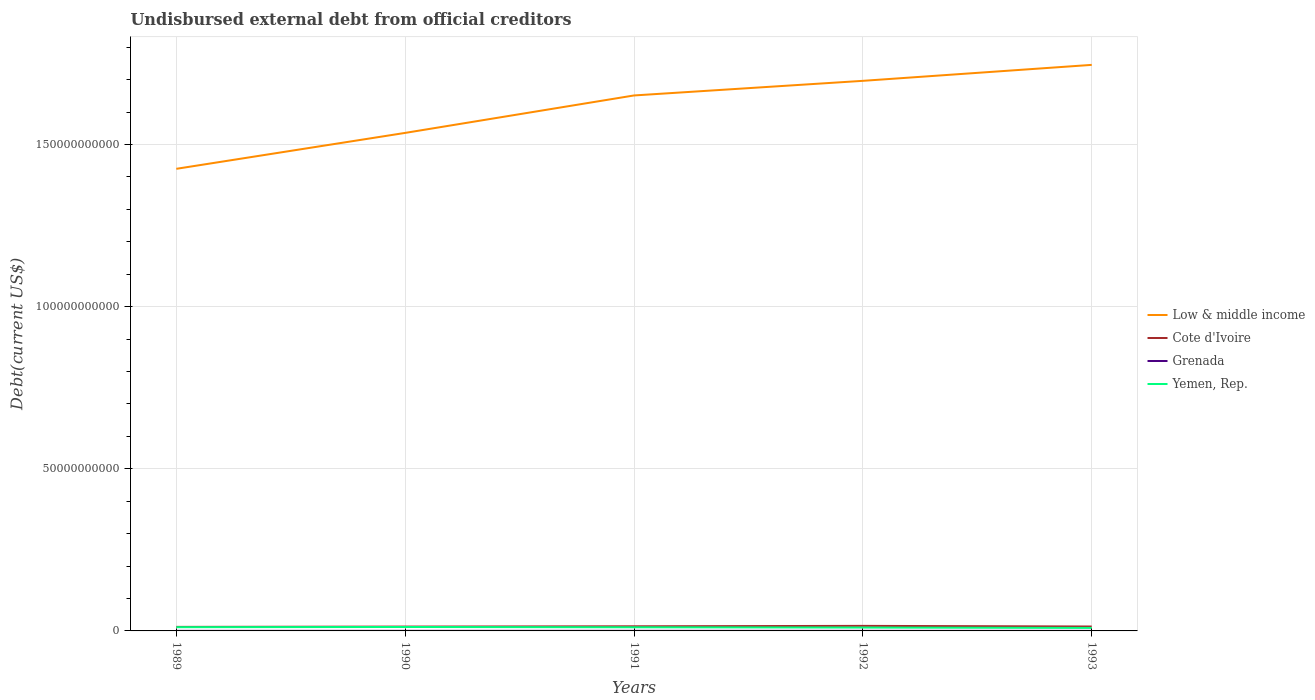Is the number of lines equal to the number of legend labels?
Ensure brevity in your answer.  Yes. Across all years, what is the maximum total debt in Grenada?
Keep it short and to the point. 1.79e+07. In which year was the total debt in Low & middle income maximum?
Give a very brief answer. 1989. What is the total total debt in Cote d'Ivoire in the graph?
Ensure brevity in your answer.  -2.43e+07. What is the difference between the highest and the second highest total debt in Grenada?
Provide a succinct answer. 8.83e+06. What is the difference between the highest and the lowest total debt in Cote d'Ivoire?
Your response must be concise. 2. How many lines are there?
Make the answer very short. 4. How many years are there in the graph?
Ensure brevity in your answer.  5. What is the difference between two consecutive major ticks on the Y-axis?
Make the answer very short. 5.00e+1. Are the values on the major ticks of Y-axis written in scientific E-notation?
Your response must be concise. No. Does the graph contain any zero values?
Your response must be concise. No. Does the graph contain grids?
Your response must be concise. Yes. How many legend labels are there?
Give a very brief answer. 4. How are the legend labels stacked?
Provide a succinct answer. Vertical. What is the title of the graph?
Make the answer very short. Undisbursed external debt from official creditors. What is the label or title of the X-axis?
Provide a succinct answer. Years. What is the label or title of the Y-axis?
Provide a succinct answer. Debt(current US$). What is the Debt(current US$) in Low & middle income in 1989?
Provide a short and direct response. 1.42e+11. What is the Debt(current US$) of Cote d'Ivoire in 1989?
Keep it short and to the point. 1.24e+09. What is the Debt(current US$) of Grenada in 1989?
Give a very brief answer. 1.99e+07. What is the Debt(current US$) in Yemen, Rep. in 1989?
Offer a terse response. 1.15e+09. What is the Debt(current US$) in Low & middle income in 1990?
Your answer should be compact. 1.54e+11. What is the Debt(current US$) in Cote d'Ivoire in 1990?
Ensure brevity in your answer.  1.33e+09. What is the Debt(current US$) of Grenada in 1990?
Offer a very short reply. 2.45e+07. What is the Debt(current US$) of Yemen, Rep. in 1990?
Ensure brevity in your answer.  1.21e+09. What is the Debt(current US$) in Low & middle income in 1991?
Your response must be concise. 1.65e+11. What is the Debt(current US$) in Cote d'Ivoire in 1991?
Your answer should be very brief. 1.43e+09. What is the Debt(current US$) in Grenada in 1991?
Offer a very short reply. 2.68e+07. What is the Debt(current US$) of Yemen, Rep. in 1991?
Your answer should be very brief. 1.12e+09. What is the Debt(current US$) of Low & middle income in 1992?
Keep it short and to the point. 1.70e+11. What is the Debt(current US$) of Cote d'Ivoire in 1992?
Ensure brevity in your answer.  1.56e+09. What is the Debt(current US$) in Grenada in 1992?
Offer a terse response. 2.27e+07. What is the Debt(current US$) of Yemen, Rep. in 1992?
Offer a terse response. 1.04e+09. What is the Debt(current US$) in Low & middle income in 1993?
Your answer should be compact. 1.75e+11. What is the Debt(current US$) of Cote d'Ivoire in 1993?
Your answer should be very brief. 1.36e+09. What is the Debt(current US$) of Grenada in 1993?
Your response must be concise. 1.79e+07. What is the Debt(current US$) in Yemen, Rep. in 1993?
Your answer should be compact. 9.25e+08. Across all years, what is the maximum Debt(current US$) in Low & middle income?
Ensure brevity in your answer.  1.75e+11. Across all years, what is the maximum Debt(current US$) of Cote d'Ivoire?
Provide a succinct answer. 1.56e+09. Across all years, what is the maximum Debt(current US$) of Grenada?
Provide a short and direct response. 2.68e+07. Across all years, what is the maximum Debt(current US$) of Yemen, Rep.?
Keep it short and to the point. 1.21e+09. Across all years, what is the minimum Debt(current US$) in Low & middle income?
Your response must be concise. 1.42e+11. Across all years, what is the minimum Debt(current US$) in Cote d'Ivoire?
Provide a succinct answer. 1.24e+09. Across all years, what is the minimum Debt(current US$) of Grenada?
Provide a short and direct response. 1.79e+07. Across all years, what is the minimum Debt(current US$) in Yemen, Rep.?
Offer a terse response. 9.25e+08. What is the total Debt(current US$) of Low & middle income in the graph?
Your response must be concise. 8.05e+11. What is the total Debt(current US$) in Cote d'Ivoire in the graph?
Provide a succinct answer. 6.92e+09. What is the total Debt(current US$) in Grenada in the graph?
Your answer should be compact. 1.12e+08. What is the total Debt(current US$) of Yemen, Rep. in the graph?
Your answer should be very brief. 5.45e+09. What is the difference between the Debt(current US$) of Low & middle income in 1989 and that in 1990?
Offer a terse response. -1.11e+1. What is the difference between the Debt(current US$) of Cote d'Ivoire in 1989 and that in 1990?
Offer a very short reply. -9.09e+07. What is the difference between the Debt(current US$) in Grenada in 1989 and that in 1990?
Give a very brief answer. -4.60e+06. What is the difference between the Debt(current US$) of Yemen, Rep. in 1989 and that in 1990?
Make the answer very short. -6.36e+07. What is the difference between the Debt(current US$) of Low & middle income in 1989 and that in 1991?
Ensure brevity in your answer.  -2.26e+1. What is the difference between the Debt(current US$) in Cote d'Ivoire in 1989 and that in 1991?
Offer a terse response. -1.83e+08. What is the difference between the Debt(current US$) in Grenada in 1989 and that in 1991?
Offer a very short reply. -6.82e+06. What is the difference between the Debt(current US$) of Yemen, Rep. in 1989 and that in 1991?
Your answer should be compact. 2.75e+07. What is the difference between the Debt(current US$) in Low & middle income in 1989 and that in 1992?
Offer a very short reply. -2.71e+1. What is the difference between the Debt(current US$) in Cote d'Ivoire in 1989 and that in 1992?
Ensure brevity in your answer.  -3.12e+08. What is the difference between the Debt(current US$) of Grenada in 1989 and that in 1992?
Offer a very short reply. -2.80e+06. What is the difference between the Debt(current US$) of Yemen, Rep. in 1989 and that in 1992?
Provide a short and direct response. 1.14e+08. What is the difference between the Debt(current US$) of Low & middle income in 1989 and that in 1993?
Give a very brief answer. -3.21e+1. What is the difference between the Debt(current US$) in Cote d'Ivoire in 1989 and that in 1993?
Give a very brief answer. -1.15e+08. What is the difference between the Debt(current US$) of Grenada in 1989 and that in 1993?
Offer a terse response. 2.01e+06. What is the difference between the Debt(current US$) of Yemen, Rep. in 1989 and that in 1993?
Your answer should be compact. 2.27e+08. What is the difference between the Debt(current US$) in Low & middle income in 1990 and that in 1991?
Ensure brevity in your answer.  -1.15e+1. What is the difference between the Debt(current US$) in Cote d'Ivoire in 1990 and that in 1991?
Your answer should be compact. -9.19e+07. What is the difference between the Debt(current US$) in Grenada in 1990 and that in 1991?
Make the answer very short. -2.22e+06. What is the difference between the Debt(current US$) of Yemen, Rep. in 1990 and that in 1991?
Provide a short and direct response. 9.11e+07. What is the difference between the Debt(current US$) in Low & middle income in 1990 and that in 1992?
Keep it short and to the point. -1.61e+1. What is the difference between the Debt(current US$) in Cote d'Ivoire in 1990 and that in 1992?
Your answer should be very brief. -2.21e+08. What is the difference between the Debt(current US$) in Grenada in 1990 and that in 1992?
Your response must be concise. 1.80e+06. What is the difference between the Debt(current US$) in Yemen, Rep. in 1990 and that in 1992?
Your response must be concise. 1.77e+08. What is the difference between the Debt(current US$) of Low & middle income in 1990 and that in 1993?
Your response must be concise. -2.10e+1. What is the difference between the Debt(current US$) in Cote d'Ivoire in 1990 and that in 1993?
Give a very brief answer. -2.43e+07. What is the difference between the Debt(current US$) in Grenada in 1990 and that in 1993?
Keep it short and to the point. 6.61e+06. What is the difference between the Debt(current US$) of Yemen, Rep. in 1990 and that in 1993?
Ensure brevity in your answer.  2.90e+08. What is the difference between the Debt(current US$) in Low & middle income in 1991 and that in 1992?
Provide a short and direct response. -4.51e+09. What is the difference between the Debt(current US$) in Cote d'Ivoire in 1991 and that in 1992?
Your answer should be compact. -1.29e+08. What is the difference between the Debt(current US$) in Grenada in 1991 and that in 1992?
Your response must be concise. 4.02e+06. What is the difference between the Debt(current US$) in Yemen, Rep. in 1991 and that in 1992?
Your answer should be compact. 8.60e+07. What is the difference between the Debt(current US$) of Low & middle income in 1991 and that in 1993?
Provide a short and direct response. -9.43e+09. What is the difference between the Debt(current US$) of Cote d'Ivoire in 1991 and that in 1993?
Keep it short and to the point. 6.76e+07. What is the difference between the Debt(current US$) of Grenada in 1991 and that in 1993?
Your answer should be very brief. 8.83e+06. What is the difference between the Debt(current US$) in Yemen, Rep. in 1991 and that in 1993?
Your answer should be compact. 1.99e+08. What is the difference between the Debt(current US$) of Low & middle income in 1992 and that in 1993?
Give a very brief answer. -4.92e+09. What is the difference between the Debt(current US$) of Cote d'Ivoire in 1992 and that in 1993?
Keep it short and to the point. 1.96e+08. What is the difference between the Debt(current US$) in Grenada in 1992 and that in 1993?
Keep it short and to the point. 4.81e+06. What is the difference between the Debt(current US$) of Yemen, Rep. in 1992 and that in 1993?
Your answer should be very brief. 1.13e+08. What is the difference between the Debt(current US$) in Low & middle income in 1989 and the Debt(current US$) in Cote d'Ivoire in 1990?
Ensure brevity in your answer.  1.41e+11. What is the difference between the Debt(current US$) of Low & middle income in 1989 and the Debt(current US$) of Grenada in 1990?
Your answer should be very brief. 1.42e+11. What is the difference between the Debt(current US$) of Low & middle income in 1989 and the Debt(current US$) of Yemen, Rep. in 1990?
Make the answer very short. 1.41e+11. What is the difference between the Debt(current US$) in Cote d'Ivoire in 1989 and the Debt(current US$) in Grenada in 1990?
Your answer should be compact. 1.22e+09. What is the difference between the Debt(current US$) of Cote d'Ivoire in 1989 and the Debt(current US$) of Yemen, Rep. in 1990?
Offer a terse response. 2.85e+07. What is the difference between the Debt(current US$) in Grenada in 1989 and the Debt(current US$) in Yemen, Rep. in 1990?
Keep it short and to the point. -1.19e+09. What is the difference between the Debt(current US$) in Low & middle income in 1989 and the Debt(current US$) in Cote d'Ivoire in 1991?
Your answer should be very brief. 1.41e+11. What is the difference between the Debt(current US$) in Low & middle income in 1989 and the Debt(current US$) in Grenada in 1991?
Offer a very short reply. 1.42e+11. What is the difference between the Debt(current US$) of Low & middle income in 1989 and the Debt(current US$) of Yemen, Rep. in 1991?
Give a very brief answer. 1.41e+11. What is the difference between the Debt(current US$) in Cote d'Ivoire in 1989 and the Debt(current US$) in Grenada in 1991?
Ensure brevity in your answer.  1.22e+09. What is the difference between the Debt(current US$) of Cote d'Ivoire in 1989 and the Debt(current US$) of Yemen, Rep. in 1991?
Make the answer very short. 1.20e+08. What is the difference between the Debt(current US$) of Grenada in 1989 and the Debt(current US$) of Yemen, Rep. in 1991?
Ensure brevity in your answer.  -1.10e+09. What is the difference between the Debt(current US$) in Low & middle income in 1989 and the Debt(current US$) in Cote d'Ivoire in 1992?
Keep it short and to the point. 1.41e+11. What is the difference between the Debt(current US$) in Low & middle income in 1989 and the Debt(current US$) in Grenada in 1992?
Ensure brevity in your answer.  1.42e+11. What is the difference between the Debt(current US$) in Low & middle income in 1989 and the Debt(current US$) in Yemen, Rep. in 1992?
Your answer should be very brief. 1.41e+11. What is the difference between the Debt(current US$) in Cote d'Ivoire in 1989 and the Debt(current US$) in Grenada in 1992?
Your response must be concise. 1.22e+09. What is the difference between the Debt(current US$) of Cote d'Ivoire in 1989 and the Debt(current US$) of Yemen, Rep. in 1992?
Give a very brief answer. 2.06e+08. What is the difference between the Debt(current US$) of Grenada in 1989 and the Debt(current US$) of Yemen, Rep. in 1992?
Keep it short and to the point. -1.02e+09. What is the difference between the Debt(current US$) of Low & middle income in 1989 and the Debt(current US$) of Cote d'Ivoire in 1993?
Ensure brevity in your answer.  1.41e+11. What is the difference between the Debt(current US$) in Low & middle income in 1989 and the Debt(current US$) in Grenada in 1993?
Ensure brevity in your answer.  1.42e+11. What is the difference between the Debt(current US$) in Low & middle income in 1989 and the Debt(current US$) in Yemen, Rep. in 1993?
Your answer should be compact. 1.42e+11. What is the difference between the Debt(current US$) in Cote d'Ivoire in 1989 and the Debt(current US$) in Grenada in 1993?
Your response must be concise. 1.23e+09. What is the difference between the Debt(current US$) in Cote d'Ivoire in 1989 and the Debt(current US$) in Yemen, Rep. in 1993?
Your response must be concise. 3.19e+08. What is the difference between the Debt(current US$) of Grenada in 1989 and the Debt(current US$) of Yemen, Rep. in 1993?
Give a very brief answer. -9.05e+08. What is the difference between the Debt(current US$) in Low & middle income in 1990 and the Debt(current US$) in Cote d'Ivoire in 1991?
Ensure brevity in your answer.  1.52e+11. What is the difference between the Debt(current US$) in Low & middle income in 1990 and the Debt(current US$) in Grenada in 1991?
Offer a terse response. 1.54e+11. What is the difference between the Debt(current US$) of Low & middle income in 1990 and the Debt(current US$) of Yemen, Rep. in 1991?
Ensure brevity in your answer.  1.52e+11. What is the difference between the Debt(current US$) of Cote d'Ivoire in 1990 and the Debt(current US$) of Grenada in 1991?
Ensure brevity in your answer.  1.31e+09. What is the difference between the Debt(current US$) of Cote d'Ivoire in 1990 and the Debt(current US$) of Yemen, Rep. in 1991?
Offer a terse response. 2.11e+08. What is the difference between the Debt(current US$) of Grenada in 1990 and the Debt(current US$) of Yemen, Rep. in 1991?
Your response must be concise. -1.10e+09. What is the difference between the Debt(current US$) of Low & middle income in 1990 and the Debt(current US$) of Cote d'Ivoire in 1992?
Ensure brevity in your answer.  1.52e+11. What is the difference between the Debt(current US$) of Low & middle income in 1990 and the Debt(current US$) of Grenada in 1992?
Ensure brevity in your answer.  1.54e+11. What is the difference between the Debt(current US$) in Low & middle income in 1990 and the Debt(current US$) in Yemen, Rep. in 1992?
Your response must be concise. 1.53e+11. What is the difference between the Debt(current US$) in Cote d'Ivoire in 1990 and the Debt(current US$) in Grenada in 1992?
Your answer should be compact. 1.31e+09. What is the difference between the Debt(current US$) in Cote d'Ivoire in 1990 and the Debt(current US$) in Yemen, Rep. in 1992?
Offer a terse response. 2.97e+08. What is the difference between the Debt(current US$) of Grenada in 1990 and the Debt(current US$) of Yemen, Rep. in 1992?
Offer a very short reply. -1.01e+09. What is the difference between the Debt(current US$) of Low & middle income in 1990 and the Debt(current US$) of Cote d'Ivoire in 1993?
Offer a terse response. 1.52e+11. What is the difference between the Debt(current US$) in Low & middle income in 1990 and the Debt(current US$) in Grenada in 1993?
Your response must be concise. 1.54e+11. What is the difference between the Debt(current US$) in Low & middle income in 1990 and the Debt(current US$) in Yemen, Rep. in 1993?
Ensure brevity in your answer.  1.53e+11. What is the difference between the Debt(current US$) in Cote d'Ivoire in 1990 and the Debt(current US$) in Grenada in 1993?
Offer a very short reply. 1.32e+09. What is the difference between the Debt(current US$) of Cote d'Ivoire in 1990 and the Debt(current US$) of Yemen, Rep. in 1993?
Give a very brief answer. 4.10e+08. What is the difference between the Debt(current US$) of Grenada in 1990 and the Debt(current US$) of Yemen, Rep. in 1993?
Provide a succinct answer. -9.00e+08. What is the difference between the Debt(current US$) of Low & middle income in 1991 and the Debt(current US$) of Cote d'Ivoire in 1992?
Make the answer very short. 1.64e+11. What is the difference between the Debt(current US$) in Low & middle income in 1991 and the Debt(current US$) in Grenada in 1992?
Your answer should be compact. 1.65e+11. What is the difference between the Debt(current US$) in Low & middle income in 1991 and the Debt(current US$) in Yemen, Rep. in 1992?
Your response must be concise. 1.64e+11. What is the difference between the Debt(current US$) of Cote d'Ivoire in 1991 and the Debt(current US$) of Grenada in 1992?
Offer a very short reply. 1.40e+09. What is the difference between the Debt(current US$) in Cote d'Ivoire in 1991 and the Debt(current US$) in Yemen, Rep. in 1992?
Your answer should be very brief. 3.88e+08. What is the difference between the Debt(current US$) of Grenada in 1991 and the Debt(current US$) of Yemen, Rep. in 1992?
Your answer should be very brief. -1.01e+09. What is the difference between the Debt(current US$) of Low & middle income in 1991 and the Debt(current US$) of Cote d'Ivoire in 1993?
Offer a terse response. 1.64e+11. What is the difference between the Debt(current US$) of Low & middle income in 1991 and the Debt(current US$) of Grenada in 1993?
Ensure brevity in your answer.  1.65e+11. What is the difference between the Debt(current US$) in Low & middle income in 1991 and the Debt(current US$) in Yemen, Rep. in 1993?
Your answer should be compact. 1.64e+11. What is the difference between the Debt(current US$) of Cote d'Ivoire in 1991 and the Debt(current US$) of Grenada in 1993?
Your response must be concise. 1.41e+09. What is the difference between the Debt(current US$) of Cote d'Ivoire in 1991 and the Debt(current US$) of Yemen, Rep. in 1993?
Offer a terse response. 5.02e+08. What is the difference between the Debt(current US$) in Grenada in 1991 and the Debt(current US$) in Yemen, Rep. in 1993?
Offer a very short reply. -8.98e+08. What is the difference between the Debt(current US$) in Low & middle income in 1992 and the Debt(current US$) in Cote d'Ivoire in 1993?
Make the answer very short. 1.68e+11. What is the difference between the Debt(current US$) of Low & middle income in 1992 and the Debt(current US$) of Grenada in 1993?
Provide a succinct answer. 1.70e+11. What is the difference between the Debt(current US$) in Low & middle income in 1992 and the Debt(current US$) in Yemen, Rep. in 1993?
Make the answer very short. 1.69e+11. What is the difference between the Debt(current US$) of Cote d'Ivoire in 1992 and the Debt(current US$) of Grenada in 1993?
Offer a terse response. 1.54e+09. What is the difference between the Debt(current US$) in Cote d'Ivoire in 1992 and the Debt(current US$) in Yemen, Rep. in 1993?
Offer a terse response. 6.31e+08. What is the difference between the Debt(current US$) of Grenada in 1992 and the Debt(current US$) of Yemen, Rep. in 1993?
Offer a very short reply. -9.02e+08. What is the average Debt(current US$) of Low & middle income per year?
Provide a short and direct response. 1.61e+11. What is the average Debt(current US$) of Cote d'Ivoire per year?
Give a very brief answer. 1.38e+09. What is the average Debt(current US$) in Grenada per year?
Offer a very short reply. 2.24e+07. What is the average Debt(current US$) of Yemen, Rep. per year?
Offer a terse response. 1.09e+09. In the year 1989, what is the difference between the Debt(current US$) in Low & middle income and Debt(current US$) in Cote d'Ivoire?
Make the answer very short. 1.41e+11. In the year 1989, what is the difference between the Debt(current US$) in Low & middle income and Debt(current US$) in Grenada?
Your answer should be very brief. 1.42e+11. In the year 1989, what is the difference between the Debt(current US$) in Low & middle income and Debt(current US$) in Yemen, Rep.?
Give a very brief answer. 1.41e+11. In the year 1989, what is the difference between the Debt(current US$) of Cote d'Ivoire and Debt(current US$) of Grenada?
Provide a succinct answer. 1.22e+09. In the year 1989, what is the difference between the Debt(current US$) of Cote d'Ivoire and Debt(current US$) of Yemen, Rep.?
Offer a terse response. 9.21e+07. In the year 1989, what is the difference between the Debt(current US$) in Grenada and Debt(current US$) in Yemen, Rep.?
Provide a short and direct response. -1.13e+09. In the year 1990, what is the difference between the Debt(current US$) of Low & middle income and Debt(current US$) of Cote d'Ivoire?
Offer a very short reply. 1.52e+11. In the year 1990, what is the difference between the Debt(current US$) in Low & middle income and Debt(current US$) in Grenada?
Your answer should be very brief. 1.54e+11. In the year 1990, what is the difference between the Debt(current US$) in Low & middle income and Debt(current US$) in Yemen, Rep.?
Offer a very short reply. 1.52e+11. In the year 1990, what is the difference between the Debt(current US$) of Cote d'Ivoire and Debt(current US$) of Grenada?
Give a very brief answer. 1.31e+09. In the year 1990, what is the difference between the Debt(current US$) of Cote d'Ivoire and Debt(current US$) of Yemen, Rep.?
Ensure brevity in your answer.  1.19e+08. In the year 1990, what is the difference between the Debt(current US$) in Grenada and Debt(current US$) in Yemen, Rep.?
Give a very brief answer. -1.19e+09. In the year 1991, what is the difference between the Debt(current US$) of Low & middle income and Debt(current US$) of Cote d'Ivoire?
Make the answer very short. 1.64e+11. In the year 1991, what is the difference between the Debt(current US$) of Low & middle income and Debt(current US$) of Grenada?
Ensure brevity in your answer.  1.65e+11. In the year 1991, what is the difference between the Debt(current US$) in Low & middle income and Debt(current US$) in Yemen, Rep.?
Offer a terse response. 1.64e+11. In the year 1991, what is the difference between the Debt(current US$) in Cote d'Ivoire and Debt(current US$) in Grenada?
Offer a very short reply. 1.40e+09. In the year 1991, what is the difference between the Debt(current US$) in Cote d'Ivoire and Debt(current US$) in Yemen, Rep.?
Provide a succinct answer. 3.02e+08. In the year 1991, what is the difference between the Debt(current US$) in Grenada and Debt(current US$) in Yemen, Rep.?
Offer a terse response. -1.10e+09. In the year 1992, what is the difference between the Debt(current US$) in Low & middle income and Debt(current US$) in Cote d'Ivoire?
Offer a very short reply. 1.68e+11. In the year 1992, what is the difference between the Debt(current US$) in Low & middle income and Debt(current US$) in Grenada?
Provide a short and direct response. 1.70e+11. In the year 1992, what is the difference between the Debt(current US$) in Low & middle income and Debt(current US$) in Yemen, Rep.?
Offer a terse response. 1.69e+11. In the year 1992, what is the difference between the Debt(current US$) in Cote d'Ivoire and Debt(current US$) in Grenada?
Ensure brevity in your answer.  1.53e+09. In the year 1992, what is the difference between the Debt(current US$) of Cote d'Ivoire and Debt(current US$) of Yemen, Rep.?
Your answer should be very brief. 5.17e+08. In the year 1992, what is the difference between the Debt(current US$) in Grenada and Debt(current US$) in Yemen, Rep.?
Offer a terse response. -1.01e+09. In the year 1993, what is the difference between the Debt(current US$) of Low & middle income and Debt(current US$) of Cote d'Ivoire?
Offer a very short reply. 1.73e+11. In the year 1993, what is the difference between the Debt(current US$) in Low & middle income and Debt(current US$) in Grenada?
Your answer should be very brief. 1.75e+11. In the year 1993, what is the difference between the Debt(current US$) of Low & middle income and Debt(current US$) of Yemen, Rep.?
Keep it short and to the point. 1.74e+11. In the year 1993, what is the difference between the Debt(current US$) of Cote d'Ivoire and Debt(current US$) of Grenada?
Make the answer very short. 1.34e+09. In the year 1993, what is the difference between the Debt(current US$) in Cote d'Ivoire and Debt(current US$) in Yemen, Rep.?
Your response must be concise. 4.34e+08. In the year 1993, what is the difference between the Debt(current US$) in Grenada and Debt(current US$) in Yemen, Rep.?
Your answer should be compact. -9.07e+08. What is the ratio of the Debt(current US$) in Low & middle income in 1989 to that in 1990?
Ensure brevity in your answer.  0.93. What is the ratio of the Debt(current US$) of Cote d'Ivoire in 1989 to that in 1990?
Give a very brief answer. 0.93. What is the ratio of the Debt(current US$) of Grenada in 1989 to that in 1990?
Ensure brevity in your answer.  0.81. What is the ratio of the Debt(current US$) in Yemen, Rep. in 1989 to that in 1990?
Ensure brevity in your answer.  0.95. What is the ratio of the Debt(current US$) in Low & middle income in 1989 to that in 1991?
Give a very brief answer. 0.86. What is the ratio of the Debt(current US$) of Cote d'Ivoire in 1989 to that in 1991?
Keep it short and to the point. 0.87. What is the ratio of the Debt(current US$) of Grenada in 1989 to that in 1991?
Offer a terse response. 0.75. What is the ratio of the Debt(current US$) in Yemen, Rep. in 1989 to that in 1991?
Offer a very short reply. 1.02. What is the ratio of the Debt(current US$) in Low & middle income in 1989 to that in 1992?
Offer a very short reply. 0.84. What is the ratio of the Debt(current US$) in Cote d'Ivoire in 1989 to that in 1992?
Provide a short and direct response. 0.8. What is the ratio of the Debt(current US$) of Grenada in 1989 to that in 1992?
Your answer should be compact. 0.88. What is the ratio of the Debt(current US$) of Yemen, Rep. in 1989 to that in 1992?
Provide a short and direct response. 1.11. What is the ratio of the Debt(current US$) in Low & middle income in 1989 to that in 1993?
Your answer should be very brief. 0.82. What is the ratio of the Debt(current US$) of Cote d'Ivoire in 1989 to that in 1993?
Provide a short and direct response. 0.92. What is the ratio of the Debt(current US$) of Grenada in 1989 to that in 1993?
Make the answer very short. 1.11. What is the ratio of the Debt(current US$) of Yemen, Rep. in 1989 to that in 1993?
Keep it short and to the point. 1.25. What is the ratio of the Debt(current US$) of Low & middle income in 1990 to that in 1991?
Provide a short and direct response. 0.93. What is the ratio of the Debt(current US$) of Cote d'Ivoire in 1990 to that in 1991?
Give a very brief answer. 0.94. What is the ratio of the Debt(current US$) in Grenada in 1990 to that in 1991?
Keep it short and to the point. 0.92. What is the ratio of the Debt(current US$) in Yemen, Rep. in 1990 to that in 1991?
Make the answer very short. 1.08. What is the ratio of the Debt(current US$) of Low & middle income in 1990 to that in 1992?
Keep it short and to the point. 0.91. What is the ratio of the Debt(current US$) of Cote d'Ivoire in 1990 to that in 1992?
Keep it short and to the point. 0.86. What is the ratio of the Debt(current US$) in Grenada in 1990 to that in 1992?
Ensure brevity in your answer.  1.08. What is the ratio of the Debt(current US$) in Yemen, Rep. in 1990 to that in 1992?
Your response must be concise. 1.17. What is the ratio of the Debt(current US$) in Low & middle income in 1990 to that in 1993?
Provide a succinct answer. 0.88. What is the ratio of the Debt(current US$) in Cote d'Ivoire in 1990 to that in 1993?
Give a very brief answer. 0.98. What is the ratio of the Debt(current US$) of Grenada in 1990 to that in 1993?
Offer a terse response. 1.37. What is the ratio of the Debt(current US$) of Yemen, Rep. in 1990 to that in 1993?
Your response must be concise. 1.31. What is the ratio of the Debt(current US$) of Low & middle income in 1991 to that in 1992?
Ensure brevity in your answer.  0.97. What is the ratio of the Debt(current US$) in Cote d'Ivoire in 1991 to that in 1992?
Your answer should be very brief. 0.92. What is the ratio of the Debt(current US$) of Grenada in 1991 to that in 1992?
Give a very brief answer. 1.18. What is the ratio of the Debt(current US$) in Yemen, Rep. in 1991 to that in 1992?
Ensure brevity in your answer.  1.08. What is the ratio of the Debt(current US$) in Low & middle income in 1991 to that in 1993?
Give a very brief answer. 0.95. What is the ratio of the Debt(current US$) of Cote d'Ivoire in 1991 to that in 1993?
Your answer should be compact. 1.05. What is the ratio of the Debt(current US$) in Grenada in 1991 to that in 1993?
Keep it short and to the point. 1.49. What is the ratio of the Debt(current US$) in Yemen, Rep. in 1991 to that in 1993?
Offer a terse response. 1.22. What is the ratio of the Debt(current US$) in Low & middle income in 1992 to that in 1993?
Give a very brief answer. 0.97. What is the ratio of the Debt(current US$) in Cote d'Ivoire in 1992 to that in 1993?
Provide a succinct answer. 1.14. What is the ratio of the Debt(current US$) in Grenada in 1992 to that in 1993?
Give a very brief answer. 1.27. What is the ratio of the Debt(current US$) in Yemen, Rep. in 1992 to that in 1993?
Make the answer very short. 1.12. What is the difference between the highest and the second highest Debt(current US$) in Low & middle income?
Your answer should be very brief. 4.92e+09. What is the difference between the highest and the second highest Debt(current US$) of Cote d'Ivoire?
Your response must be concise. 1.29e+08. What is the difference between the highest and the second highest Debt(current US$) of Grenada?
Keep it short and to the point. 2.22e+06. What is the difference between the highest and the second highest Debt(current US$) in Yemen, Rep.?
Provide a short and direct response. 6.36e+07. What is the difference between the highest and the lowest Debt(current US$) in Low & middle income?
Your answer should be very brief. 3.21e+1. What is the difference between the highest and the lowest Debt(current US$) in Cote d'Ivoire?
Provide a succinct answer. 3.12e+08. What is the difference between the highest and the lowest Debt(current US$) in Grenada?
Your response must be concise. 8.83e+06. What is the difference between the highest and the lowest Debt(current US$) of Yemen, Rep.?
Your answer should be very brief. 2.90e+08. 